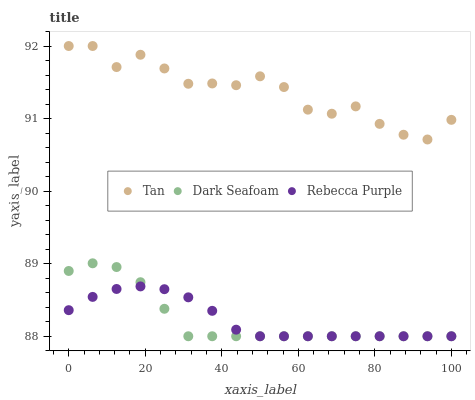Does Dark Seafoam have the minimum area under the curve?
Answer yes or no. Yes. Does Tan have the maximum area under the curve?
Answer yes or no. Yes. Does Rebecca Purple have the minimum area under the curve?
Answer yes or no. No. Does Rebecca Purple have the maximum area under the curve?
Answer yes or no. No. Is Rebecca Purple the smoothest?
Answer yes or no. Yes. Is Tan the roughest?
Answer yes or no. Yes. Is Dark Seafoam the smoothest?
Answer yes or no. No. Is Dark Seafoam the roughest?
Answer yes or no. No. Does Dark Seafoam have the lowest value?
Answer yes or no. Yes. Does Tan have the highest value?
Answer yes or no. Yes. Does Dark Seafoam have the highest value?
Answer yes or no. No. Is Rebecca Purple less than Tan?
Answer yes or no. Yes. Is Tan greater than Rebecca Purple?
Answer yes or no. Yes. Does Dark Seafoam intersect Rebecca Purple?
Answer yes or no. Yes. Is Dark Seafoam less than Rebecca Purple?
Answer yes or no. No. Is Dark Seafoam greater than Rebecca Purple?
Answer yes or no. No. Does Rebecca Purple intersect Tan?
Answer yes or no. No. 